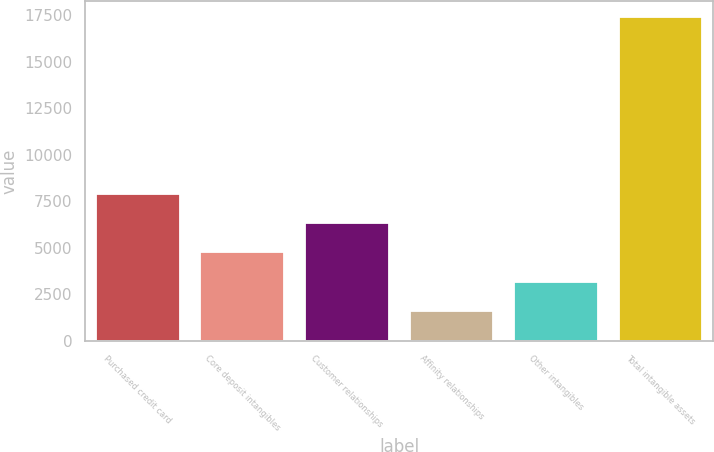<chart> <loc_0><loc_0><loc_500><loc_500><bar_chart><fcel>Purchased credit card<fcel>Core deposit intangibles<fcel>Customer relationships<fcel>Affinity relationships<fcel>Other intangibles<fcel>Total intangible assets<nl><fcel>7903.8<fcel>4739.4<fcel>6321.6<fcel>1575<fcel>3157.2<fcel>17397<nl></chart> 